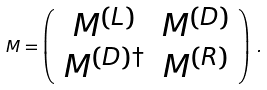<formula> <loc_0><loc_0><loc_500><loc_500>M = \left ( \begin{array} { c c } M ^ { ( L ) } & M ^ { ( D ) } \\ M ^ { ( D ) \dagger } & M ^ { ( R ) } \end{array} \right ) \, .</formula> 